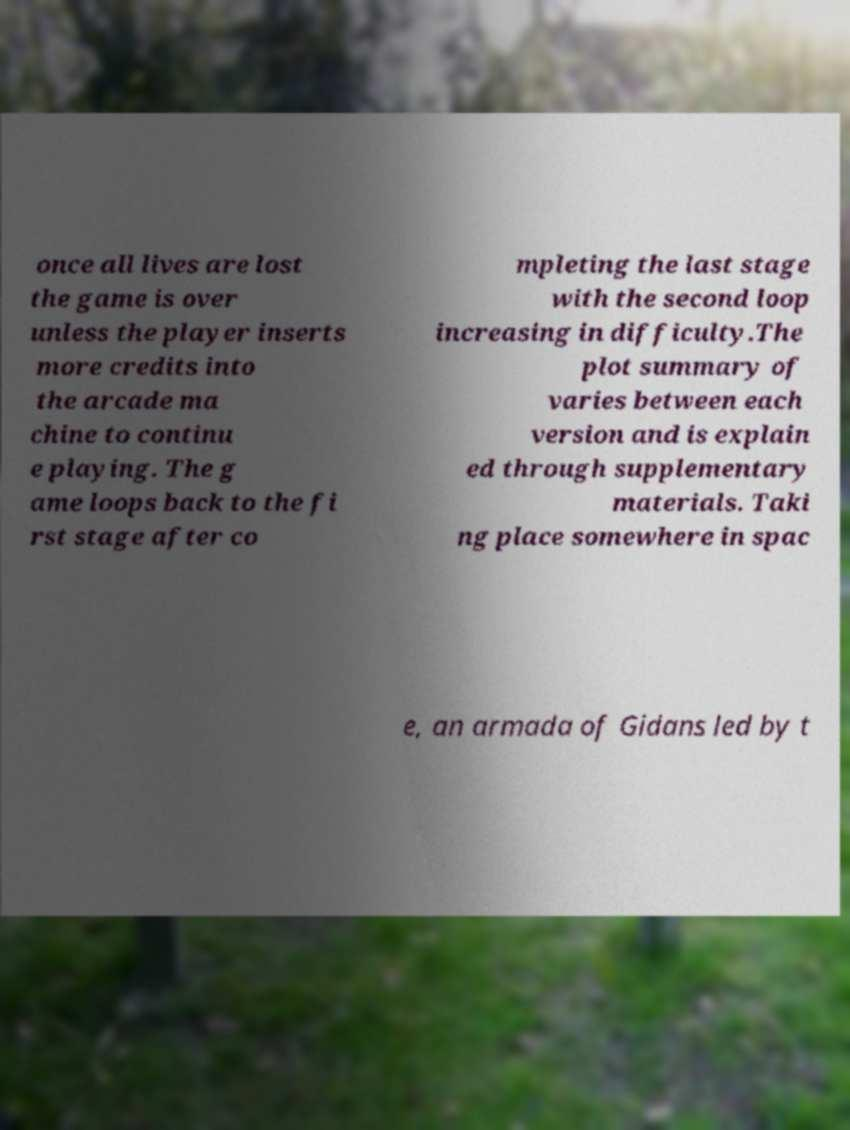For documentation purposes, I need the text within this image transcribed. Could you provide that? once all lives are lost the game is over unless the player inserts more credits into the arcade ma chine to continu e playing. The g ame loops back to the fi rst stage after co mpleting the last stage with the second loop increasing in difficulty.The plot summary of varies between each version and is explain ed through supplementary materials. Taki ng place somewhere in spac e, an armada of Gidans led by t 